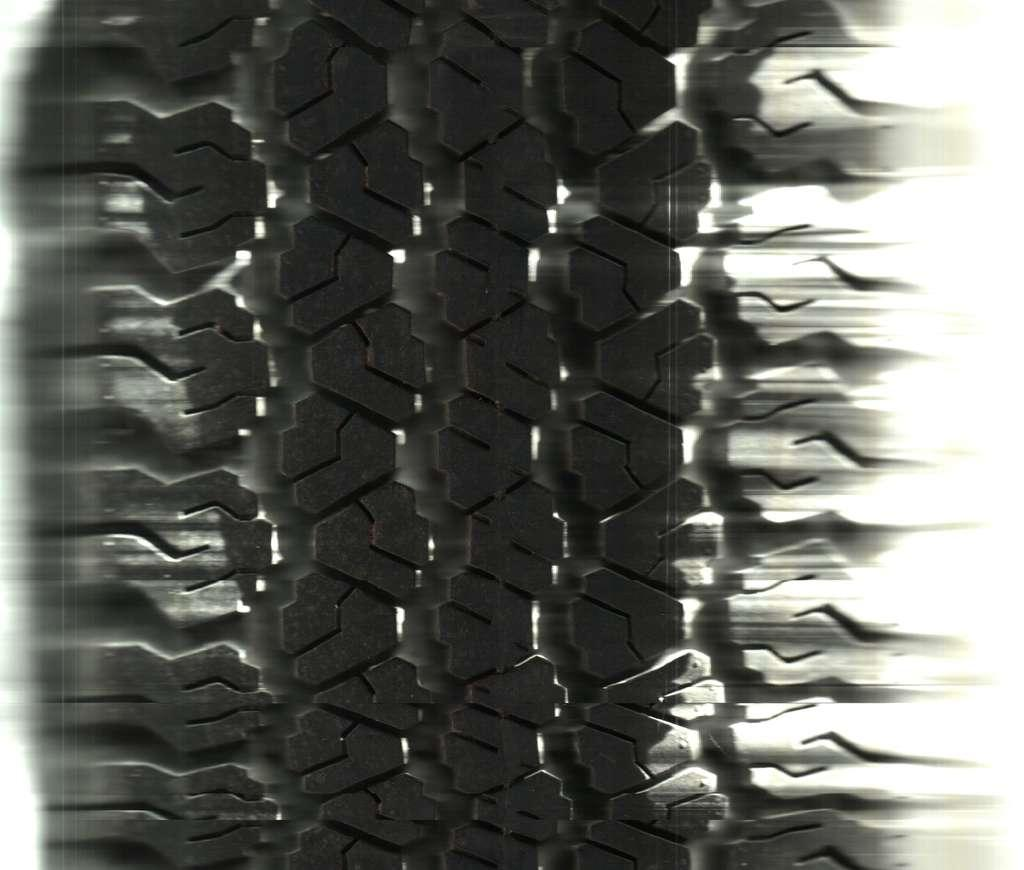What object can be seen in the image? There is a black tire in the image. How many roses are growing in the pot in the image? There is no pot or roses present in the image; it only features a black tire. 